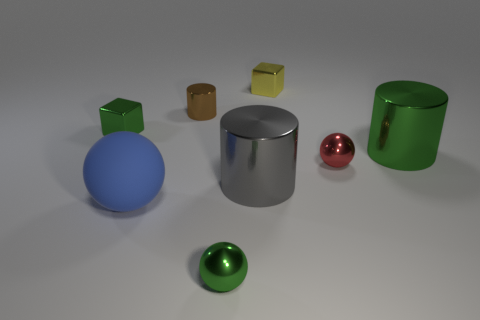Add 1 tiny yellow things. How many objects exist? 9 Subtract all blocks. How many objects are left? 6 Add 6 large green cylinders. How many large green cylinders are left? 7 Add 7 brown objects. How many brown objects exist? 8 Subtract 0 yellow cylinders. How many objects are left? 8 Subtract all small yellow matte cylinders. Subtract all big blue balls. How many objects are left? 7 